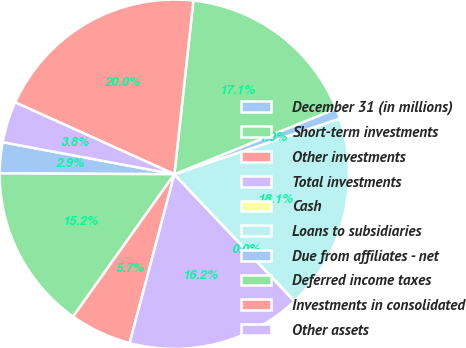Convert chart to OTSL. <chart><loc_0><loc_0><loc_500><loc_500><pie_chart><fcel>December 31 (in millions)<fcel>Short-term investments<fcel>Other investments<fcel>Total investments<fcel>Cash<fcel>Loans to subsidiaries<fcel>Due from affiliates - net<fcel>Deferred income taxes<fcel>Investments in consolidated<fcel>Other assets<nl><fcel>2.86%<fcel>15.24%<fcel>5.72%<fcel>16.19%<fcel>0.01%<fcel>18.09%<fcel>0.96%<fcel>17.14%<fcel>19.99%<fcel>3.81%<nl></chart> 